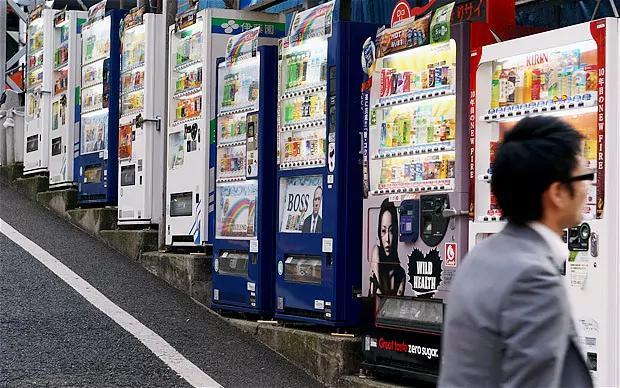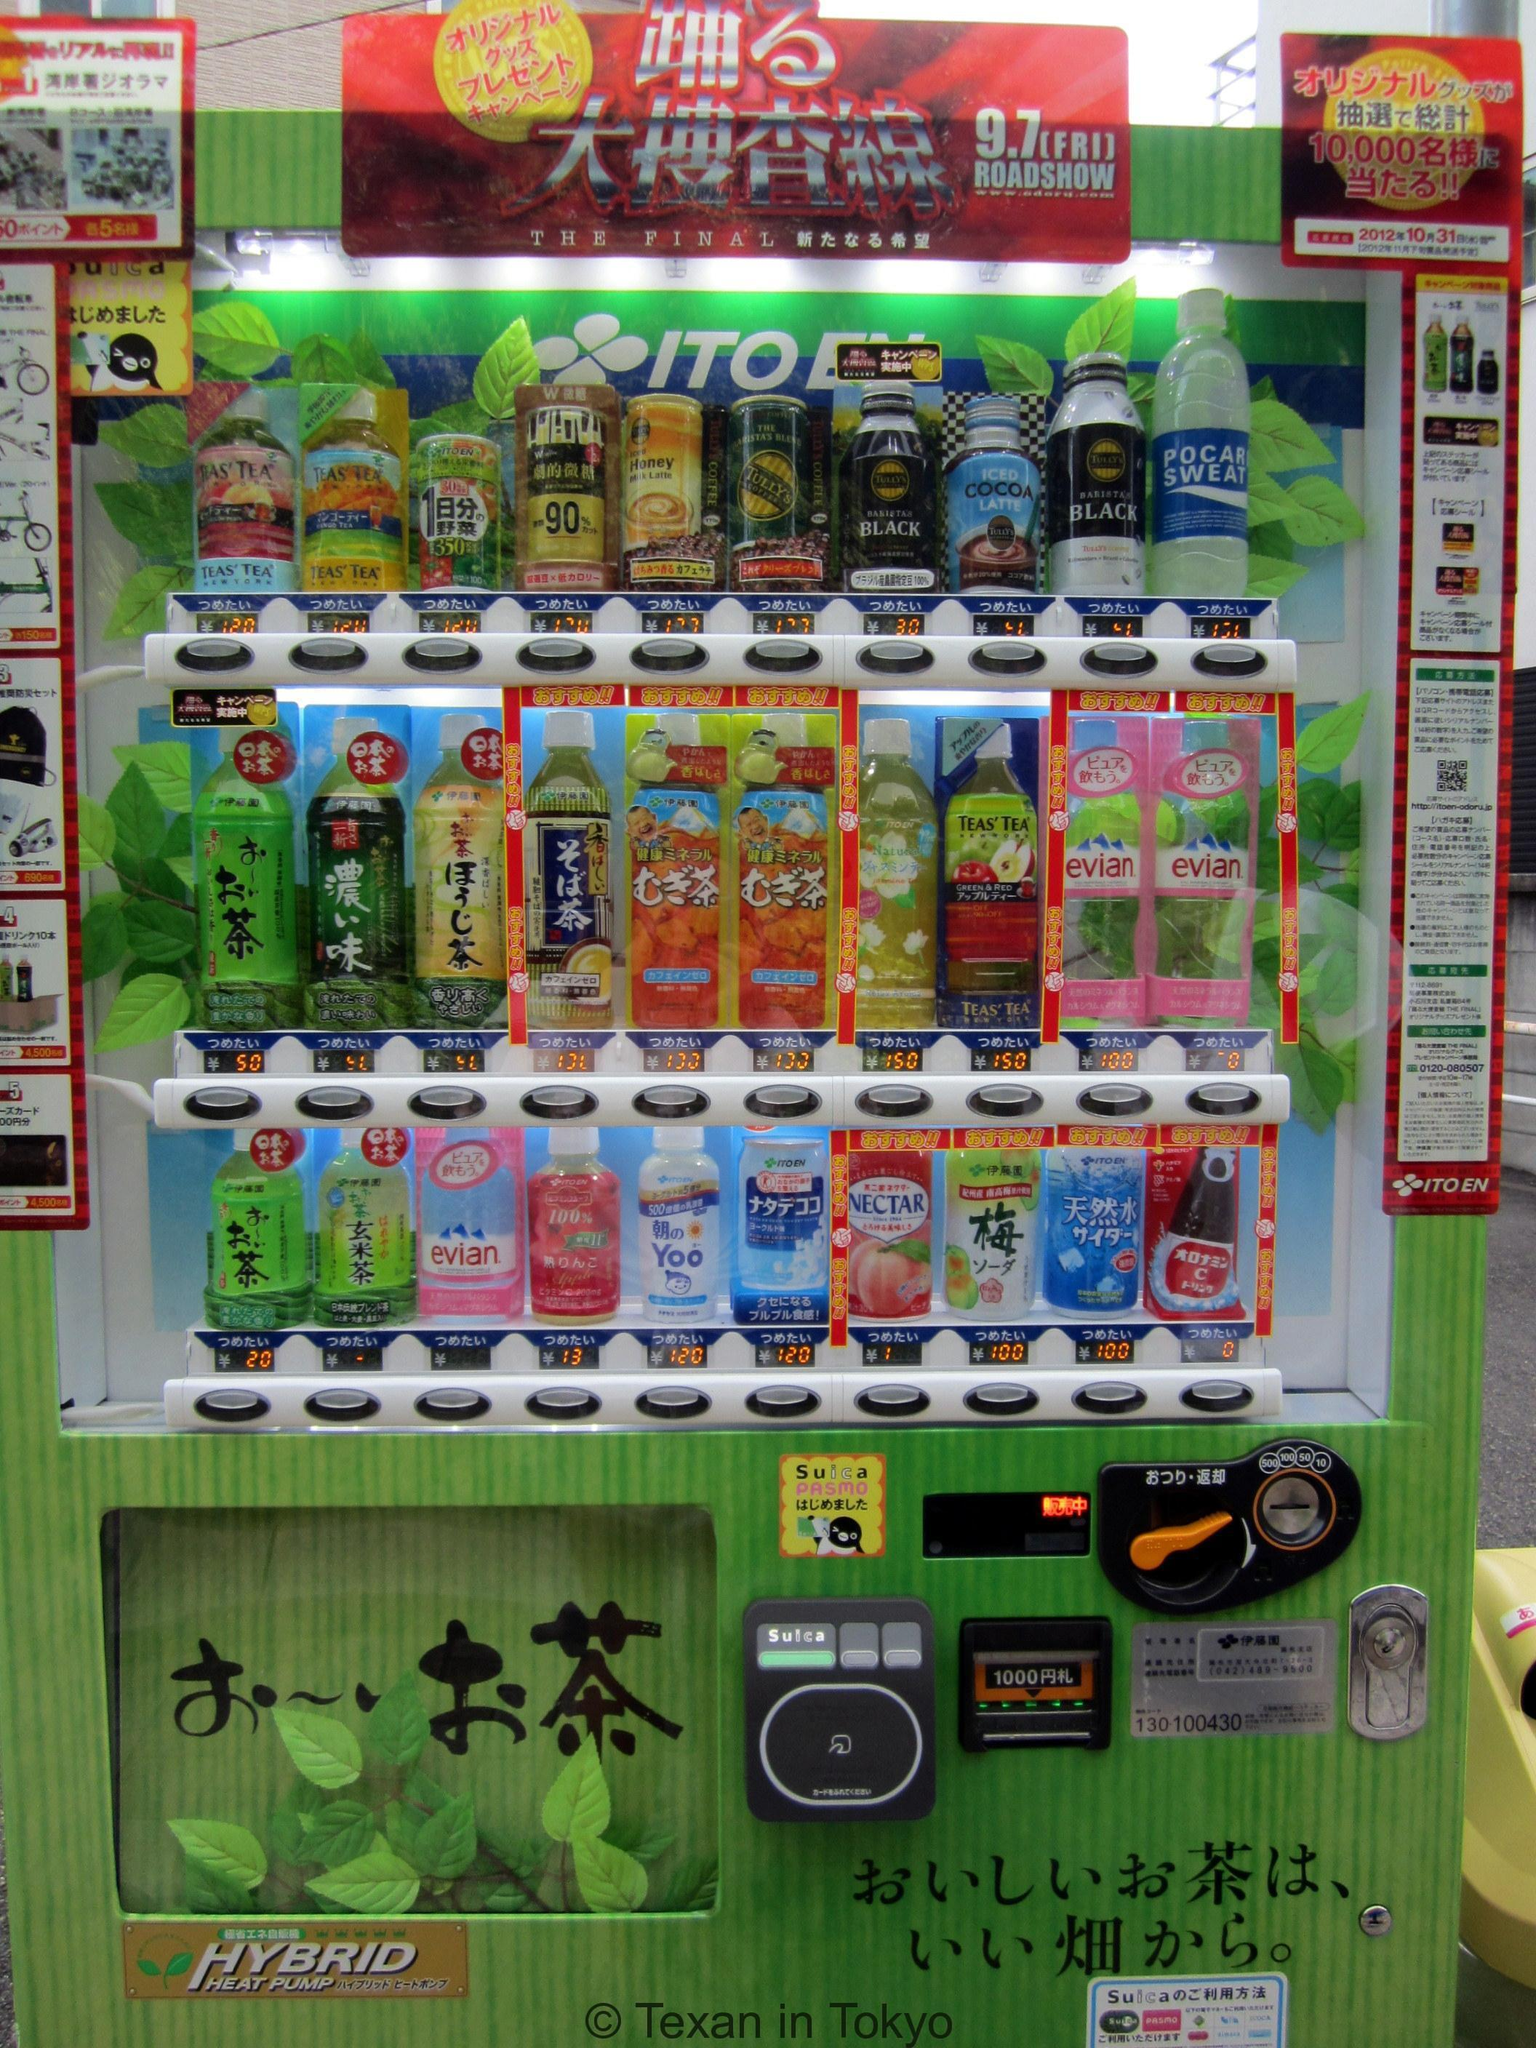The first image is the image on the left, the second image is the image on the right. Assess this claim about the two images: "The right image only has one vending machine.". Correct or not? Answer yes or no. Yes. 